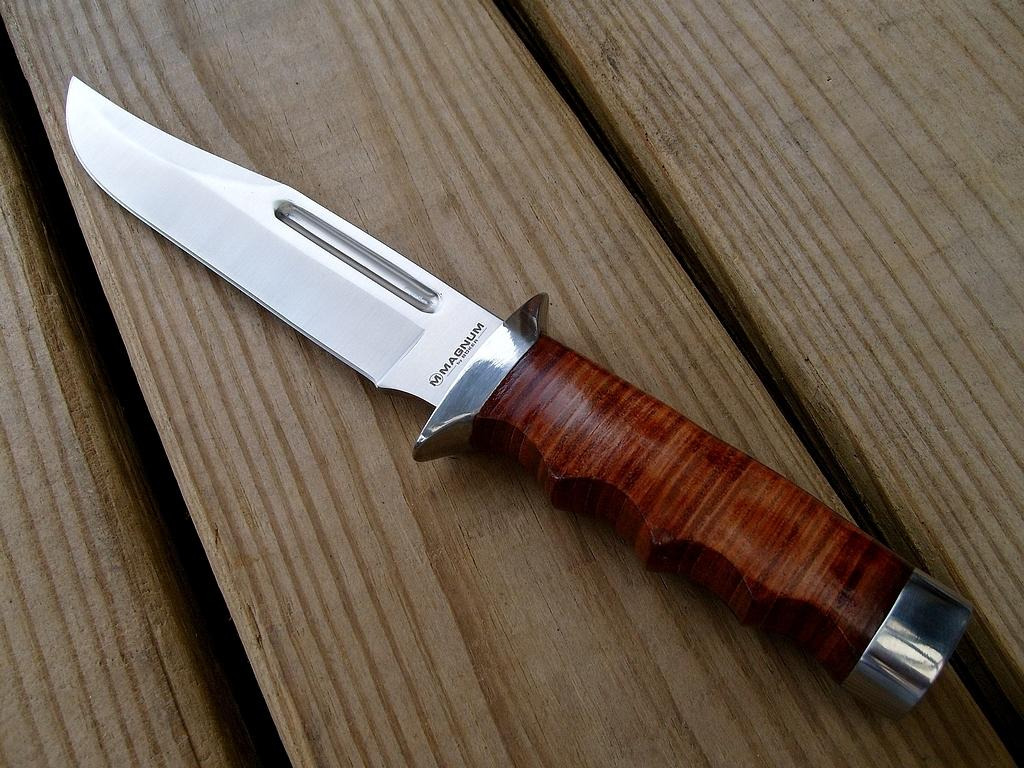What object can be seen in the image? There is a knife in the image. Where is the knife located? The knife is on a wooden table. What material is the knife holder made of? The knife holder is made of wood. How much profit does the friend make from the furniture in the image? There is no mention of a friend or furniture in the image, so it is not possible to determine any profit. 